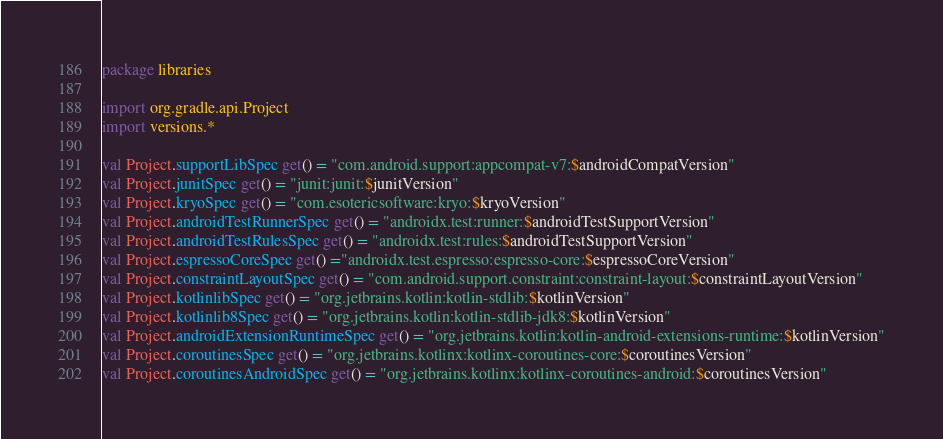<code> <loc_0><loc_0><loc_500><loc_500><_Kotlin_>package libraries

import org.gradle.api.Project
import versions.*

val Project.supportLibSpec get() = "com.android.support:appcompat-v7:$androidCompatVersion"
val Project.junitSpec get() = "junit:junit:$junitVersion"
val Project.kryoSpec get() = "com.esotericsoftware:kryo:$kryoVersion"
val Project.androidTestRunnerSpec get() = "androidx.test:runner:$androidTestSupportVersion"
val Project.androidTestRulesSpec get() = "androidx.test:rules:$androidTestSupportVersion"
val Project.espressoCoreSpec get() ="androidx.test.espresso:espresso-core:$espressoCoreVersion"
val Project.constraintLayoutSpec get() = "com.android.support.constraint:constraint-layout:$constraintLayoutVersion"
val Project.kotlinlibSpec get() = "org.jetbrains.kotlin:kotlin-stdlib:$kotlinVersion"
val Project.kotlinlib8Spec get() = "org.jetbrains.kotlin:kotlin-stdlib-jdk8:$kotlinVersion"
val Project.androidExtensionRuntimeSpec get() = "org.jetbrains.kotlin:kotlin-android-extensions-runtime:$kotlinVersion"
val Project.coroutinesSpec get() = "org.jetbrains.kotlinx:kotlinx-coroutines-core:$coroutinesVersion"
val Project.coroutinesAndroidSpec get() = "org.jetbrains.kotlinx:kotlinx-coroutines-android:$coroutinesVersion"
</code> 